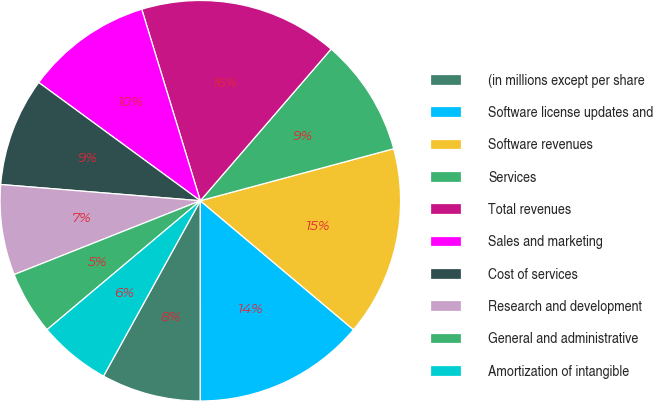<chart> <loc_0><loc_0><loc_500><loc_500><pie_chart><fcel>(in millions except per share<fcel>Software license updates and<fcel>Software revenues<fcel>Services<fcel>Total revenues<fcel>Sales and marketing<fcel>Cost of services<fcel>Research and development<fcel>General and administrative<fcel>Amortization of intangible<nl><fcel>8.03%<fcel>13.86%<fcel>15.32%<fcel>9.49%<fcel>16.05%<fcel>10.22%<fcel>8.76%<fcel>7.3%<fcel>5.12%<fcel>5.84%<nl></chart> 